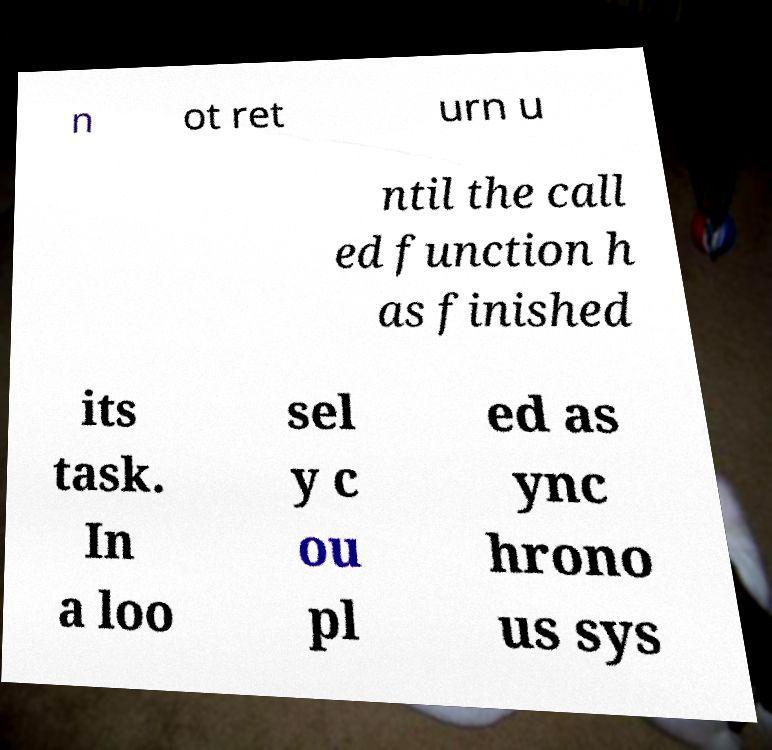Can you read and provide the text displayed in the image?This photo seems to have some interesting text. Can you extract and type it out for me? n ot ret urn u ntil the call ed function h as finished its task. In a loo sel y c ou pl ed as ync hrono us sys 